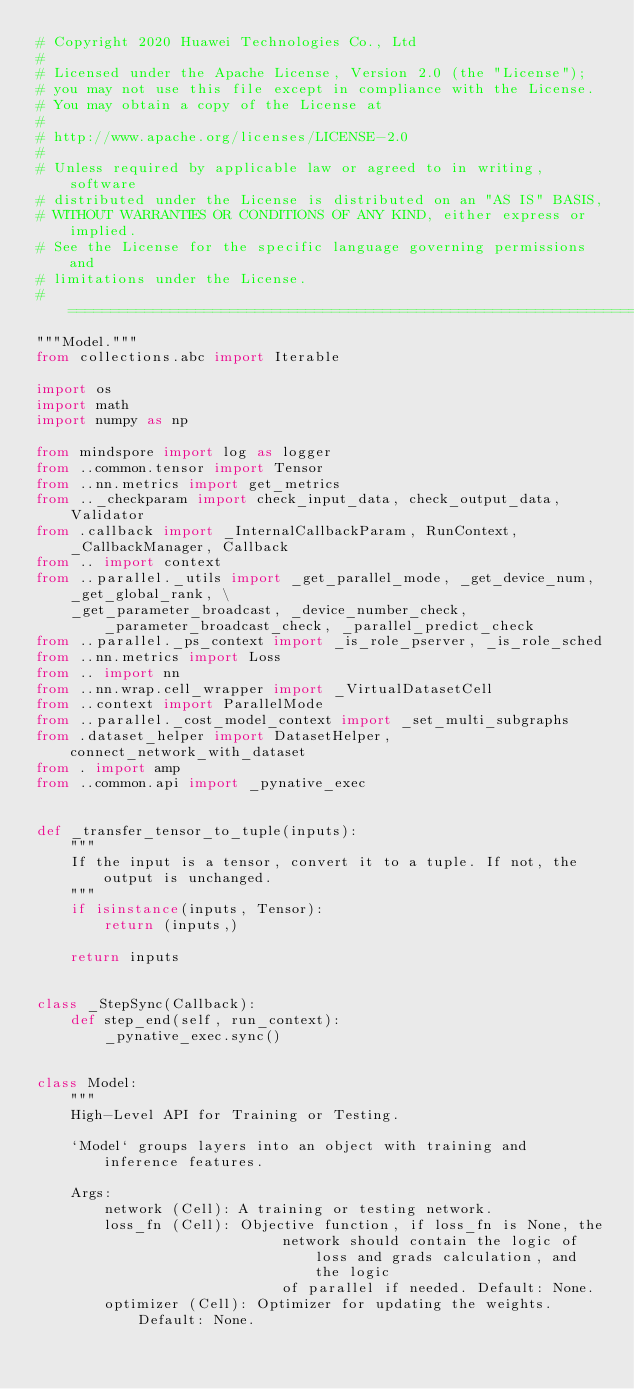Convert code to text. <code><loc_0><loc_0><loc_500><loc_500><_Python_># Copyright 2020 Huawei Technologies Co., Ltd
#
# Licensed under the Apache License, Version 2.0 (the "License");
# you may not use this file except in compliance with the License.
# You may obtain a copy of the License at
#
# http://www.apache.org/licenses/LICENSE-2.0
#
# Unless required by applicable law or agreed to in writing, software
# distributed under the License is distributed on an "AS IS" BASIS,
# WITHOUT WARRANTIES OR CONDITIONS OF ANY KIND, either express or implied.
# See the License for the specific language governing permissions and
# limitations under the License.
# ============================================================================
"""Model."""
from collections.abc import Iterable

import os
import math
import numpy as np

from mindspore import log as logger
from ..common.tensor import Tensor
from ..nn.metrics import get_metrics
from .._checkparam import check_input_data, check_output_data, Validator
from .callback import _InternalCallbackParam, RunContext, _CallbackManager, Callback
from .. import context
from ..parallel._utils import _get_parallel_mode, _get_device_num, _get_global_rank, \
    _get_parameter_broadcast, _device_number_check, _parameter_broadcast_check, _parallel_predict_check
from ..parallel._ps_context import _is_role_pserver, _is_role_sched
from ..nn.metrics import Loss
from .. import nn
from ..nn.wrap.cell_wrapper import _VirtualDatasetCell
from ..context import ParallelMode
from ..parallel._cost_model_context import _set_multi_subgraphs
from .dataset_helper import DatasetHelper, connect_network_with_dataset
from . import amp
from ..common.api import _pynative_exec


def _transfer_tensor_to_tuple(inputs):
    """
    If the input is a tensor, convert it to a tuple. If not, the output is unchanged.
    """
    if isinstance(inputs, Tensor):
        return (inputs,)

    return inputs


class _StepSync(Callback):
    def step_end(self, run_context):
        _pynative_exec.sync()


class Model:
    """
    High-Level API for Training or Testing.

    `Model` groups layers into an object with training and inference features.

    Args:
        network (Cell): A training or testing network.
        loss_fn (Cell): Objective function, if loss_fn is None, the
                             network should contain the logic of loss and grads calculation, and the logic
                             of parallel if needed. Default: None.
        optimizer (Cell): Optimizer for updating the weights. Default: None.</code> 